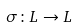<formula> <loc_0><loc_0><loc_500><loc_500>\sigma \colon L \rightarrow L</formula> 